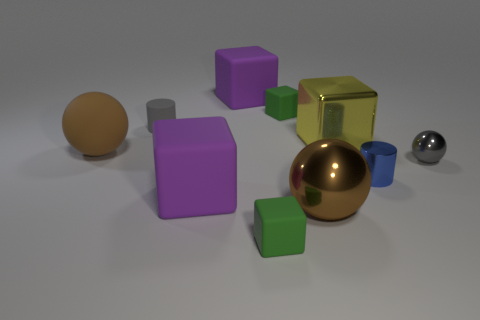There is a purple rubber thing in front of the large purple block that is behind the large yellow metallic thing; what size is it?
Your answer should be compact. Large. What shape is the thing that is the same color as the small ball?
Give a very brief answer. Cylinder. How many cubes are blue metal things or small gray metal objects?
Offer a very short reply. 0. Do the brown metallic sphere and the blue metal cylinder on the left side of the gray sphere have the same size?
Make the answer very short. No. Is the number of big brown metallic objects that are on the right side of the shiny cube greater than the number of gray balls?
Your response must be concise. No. There is a blue cylinder that is made of the same material as the large yellow block; what is its size?
Offer a very short reply. Small. Is there another small cylinder that has the same color as the metallic cylinder?
Ensure brevity in your answer.  No. What number of objects are either tiny metal things or tiny green objects that are behind the gray shiny thing?
Keep it short and to the point. 3. Is the number of large brown objects greater than the number of tiny brown cylinders?
Keep it short and to the point. Yes. What size is the metal thing that is the same color as the rubber ball?
Keep it short and to the point. Large. 